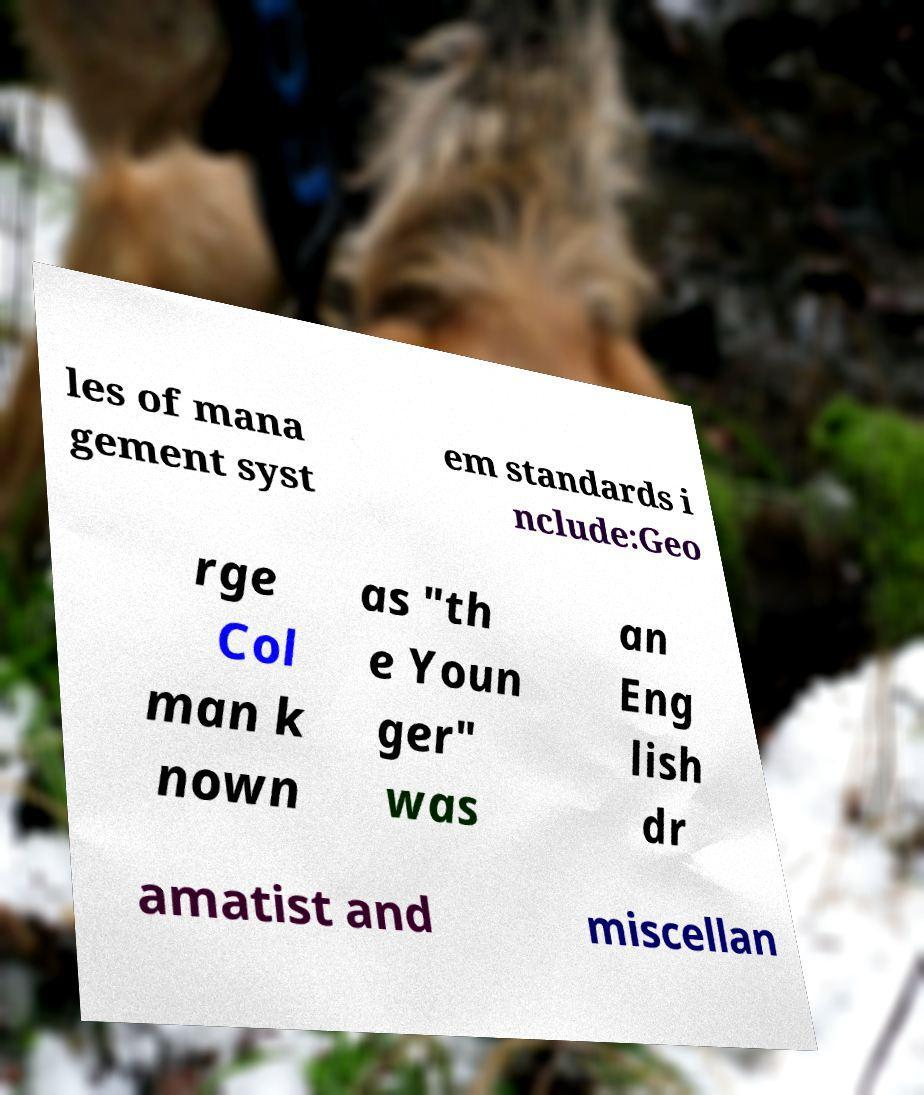Please read and relay the text visible in this image. What does it say? les of mana gement syst em standards i nclude:Geo rge Col man k nown as "th e Youn ger" was an Eng lish dr amatist and miscellan 